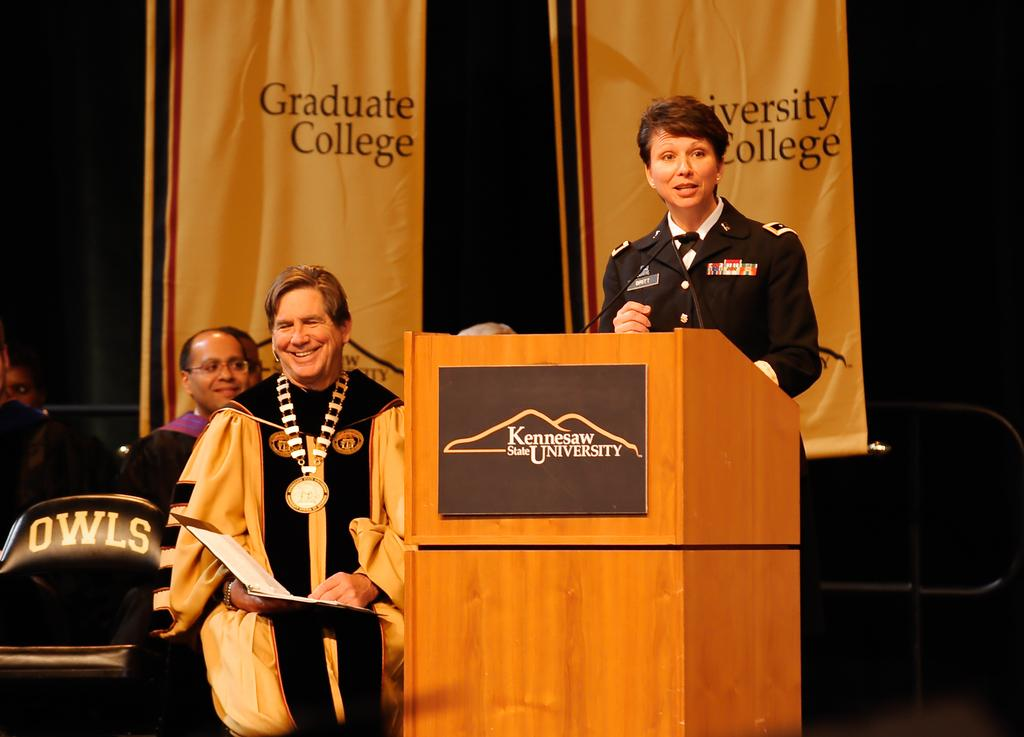What is the woman in the image doing? The woman is standing in front of a podium. Are there any other people in the image? Yes, there are men standing beside the woman. What can be seen in the background of the image? There is a black curtain and two banners in the background. What type of cable is being used on the desk in the image? There is no desk present in the image, so it is not possible to determine if any cables are being used. 